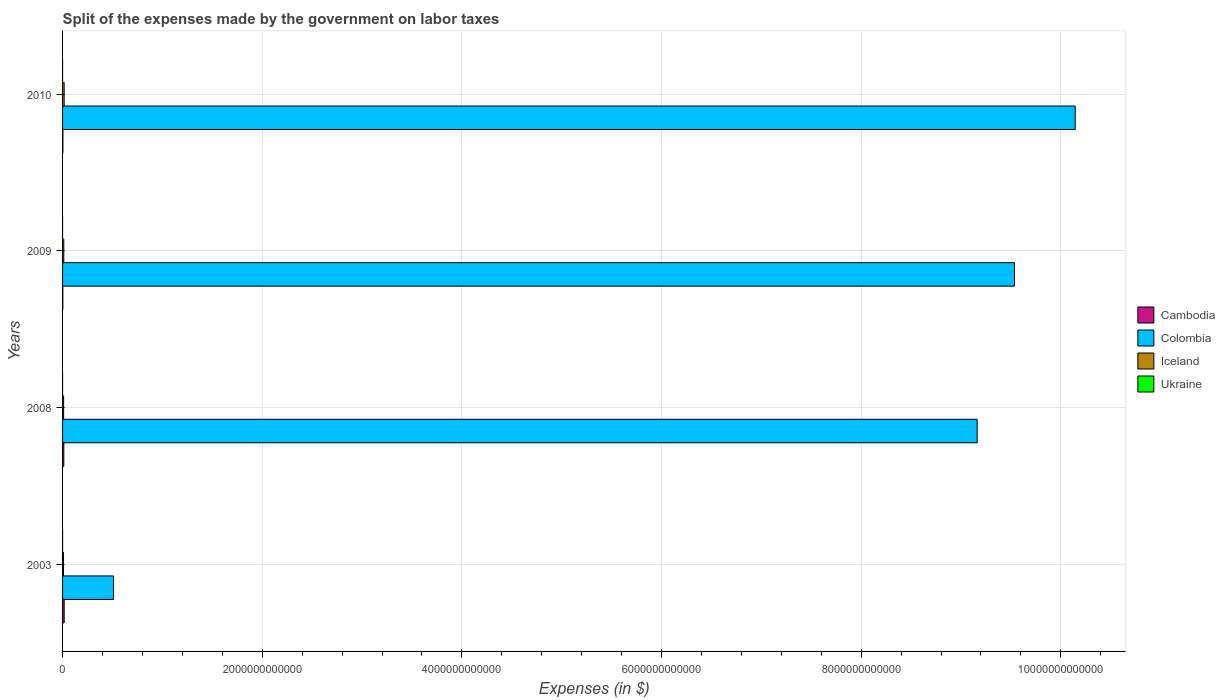How many different coloured bars are there?
Make the answer very short. 4. In how many cases, is the number of bars for a given year not equal to the number of legend labels?
Provide a succinct answer. 0. What is the expenses made by the government on labor taxes in Colombia in 2008?
Provide a short and direct response. 9.16e+12. Across all years, what is the maximum expenses made by the government on labor taxes in Iceland?
Provide a succinct answer. 1.59e+1. Across all years, what is the minimum expenses made by the government on labor taxes in Colombia?
Make the answer very short. 5.11e+11. In which year was the expenses made by the government on labor taxes in Colombia minimum?
Provide a short and direct response. 2003. What is the total expenses made by the government on labor taxes in Iceland in the graph?
Offer a very short reply. 4.86e+1. What is the difference between the expenses made by the government on labor taxes in Iceland in 2003 and that in 2008?
Provide a short and direct response. -9.53e+08. What is the difference between the expenses made by the government on labor taxes in Colombia in 2010 and the expenses made by the government on labor taxes in Cambodia in 2008?
Ensure brevity in your answer.  1.01e+13. What is the average expenses made by the government on labor taxes in Ukraine per year?
Your answer should be very brief. 2.12e+07. In the year 2010, what is the difference between the expenses made by the government on labor taxes in Ukraine and expenses made by the government on labor taxes in Cambodia?
Offer a very short reply. -3.40e+09. In how many years, is the expenses made by the government on labor taxes in Cambodia greater than 9200000000000 $?
Provide a succinct answer. 0. What is the ratio of the expenses made by the government on labor taxes in Ukraine in 2003 to that in 2009?
Make the answer very short. 43.6. Is the expenses made by the government on labor taxes in Iceland in 2003 less than that in 2010?
Provide a succinct answer. Yes. What is the difference between the highest and the second highest expenses made by the government on labor taxes in Colombia?
Offer a terse response. 6.08e+11. What is the difference between the highest and the lowest expenses made by the government on labor taxes in Ukraine?
Provide a succinct answer. 7.74e+07. In how many years, is the expenses made by the government on labor taxes in Iceland greater than the average expenses made by the government on labor taxes in Iceland taken over all years?
Provide a short and direct response. 2. How many years are there in the graph?
Make the answer very short. 4. What is the difference between two consecutive major ticks on the X-axis?
Your response must be concise. 2.00e+12. Are the values on the major ticks of X-axis written in scientific E-notation?
Make the answer very short. No. Does the graph contain any zero values?
Keep it short and to the point. No. Does the graph contain grids?
Offer a terse response. Yes. What is the title of the graph?
Your answer should be very brief. Split of the expenses made by the government on labor taxes. Does "Faeroe Islands" appear as one of the legend labels in the graph?
Keep it short and to the point. No. What is the label or title of the X-axis?
Offer a very short reply. Expenses (in $). What is the Expenses (in $) of Cambodia in 2003?
Your answer should be compact. 1.63e+1. What is the Expenses (in $) in Colombia in 2003?
Make the answer very short. 5.11e+11. What is the Expenses (in $) of Iceland in 2003?
Make the answer very short. 9.70e+09. What is the Expenses (in $) in Ukraine in 2003?
Offer a very short reply. 7.85e+07. What is the Expenses (in $) in Cambodia in 2008?
Provide a short and direct response. 1.25e+1. What is the Expenses (in $) in Colombia in 2008?
Offer a very short reply. 9.16e+12. What is the Expenses (in $) of Iceland in 2008?
Keep it short and to the point. 1.06e+1. What is the Expenses (in $) of Ukraine in 2008?
Offer a terse response. 3.44e+06. What is the Expenses (in $) of Cambodia in 2009?
Offer a terse response. 2.63e+09. What is the Expenses (in $) in Colombia in 2009?
Ensure brevity in your answer.  9.54e+12. What is the Expenses (in $) of Iceland in 2009?
Provide a succinct answer. 1.23e+1. What is the Expenses (in $) of Ukraine in 2009?
Offer a very short reply. 1.80e+06. What is the Expenses (in $) of Cambodia in 2010?
Your answer should be compact. 3.40e+09. What is the Expenses (in $) in Colombia in 2010?
Give a very brief answer. 1.01e+13. What is the Expenses (in $) in Iceland in 2010?
Your answer should be compact. 1.59e+1. What is the Expenses (in $) in Ukraine in 2010?
Provide a short and direct response. 1.08e+06. Across all years, what is the maximum Expenses (in $) of Cambodia?
Ensure brevity in your answer.  1.63e+1. Across all years, what is the maximum Expenses (in $) of Colombia?
Offer a very short reply. 1.01e+13. Across all years, what is the maximum Expenses (in $) of Iceland?
Give a very brief answer. 1.59e+1. Across all years, what is the maximum Expenses (in $) in Ukraine?
Provide a succinct answer. 7.85e+07. Across all years, what is the minimum Expenses (in $) in Cambodia?
Offer a very short reply. 2.63e+09. Across all years, what is the minimum Expenses (in $) of Colombia?
Your answer should be compact. 5.11e+11. Across all years, what is the minimum Expenses (in $) of Iceland?
Offer a terse response. 9.70e+09. Across all years, what is the minimum Expenses (in $) of Ukraine?
Keep it short and to the point. 1.08e+06. What is the total Expenses (in $) of Cambodia in the graph?
Your answer should be very brief. 3.48e+1. What is the total Expenses (in $) of Colombia in the graph?
Offer a terse response. 2.94e+13. What is the total Expenses (in $) of Iceland in the graph?
Make the answer very short. 4.86e+1. What is the total Expenses (in $) in Ukraine in the graph?
Provide a short and direct response. 8.48e+07. What is the difference between the Expenses (in $) in Cambodia in 2003 and that in 2008?
Give a very brief answer. 3.84e+09. What is the difference between the Expenses (in $) of Colombia in 2003 and that in 2008?
Your answer should be compact. -8.65e+12. What is the difference between the Expenses (in $) of Iceland in 2003 and that in 2008?
Offer a very short reply. -9.53e+08. What is the difference between the Expenses (in $) in Ukraine in 2003 and that in 2008?
Make the answer very short. 7.50e+07. What is the difference between the Expenses (in $) of Cambodia in 2003 and that in 2009?
Provide a short and direct response. 1.37e+1. What is the difference between the Expenses (in $) in Colombia in 2003 and that in 2009?
Ensure brevity in your answer.  -9.03e+12. What is the difference between the Expenses (in $) of Iceland in 2003 and that in 2009?
Provide a short and direct response. -2.65e+09. What is the difference between the Expenses (in $) in Ukraine in 2003 and that in 2009?
Your answer should be compact. 7.67e+07. What is the difference between the Expenses (in $) of Cambodia in 2003 and that in 2010?
Provide a succinct answer. 1.29e+1. What is the difference between the Expenses (in $) in Colombia in 2003 and that in 2010?
Make the answer very short. -9.63e+12. What is the difference between the Expenses (in $) in Iceland in 2003 and that in 2010?
Give a very brief answer. -6.17e+09. What is the difference between the Expenses (in $) of Ukraine in 2003 and that in 2010?
Your response must be concise. 7.74e+07. What is the difference between the Expenses (in $) of Cambodia in 2008 and that in 2009?
Your answer should be compact. 9.85e+09. What is the difference between the Expenses (in $) of Colombia in 2008 and that in 2009?
Make the answer very short. -3.74e+11. What is the difference between the Expenses (in $) of Iceland in 2008 and that in 2009?
Offer a very short reply. -1.70e+09. What is the difference between the Expenses (in $) in Ukraine in 2008 and that in 2009?
Make the answer very short. 1.64e+06. What is the difference between the Expenses (in $) in Cambodia in 2008 and that in 2010?
Offer a terse response. 9.07e+09. What is the difference between the Expenses (in $) of Colombia in 2008 and that in 2010?
Your answer should be very brief. -9.82e+11. What is the difference between the Expenses (in $) in Iceland in 2008 and that in 2010?
Make the answer very short. -5.21e+09. What is the difference between the Expenses (in $) in Ukraine in 2008 and that in 2010?
Provide a succinct answer. 2.36e+06. What is the difference between the Expenses (in $) in Cambodia in 2009 and that in 2010?
Ensure brevity in your answer.  -7.72e+08. What is the difference between the Expenses (in $) in Colombia in 2009 and that in 2010?
Keep it short and to the point. -6.08e+11. What is the difference between the Expenses (in $) of Iceland in 2009 and that in 2010?
Your response must be concise. -3.52e+09. What is the difference between the Expenses (in $) in Ukraine in 2009 and that in 2010?
Provide a succinct answer. 7.20e+05. What is the difference between the Expenses (in $) in Cambodia in 2003 and the Expenses (in $) in Colombia in 2008?
Give a very brief answer. -9.15e+12. What is the difference between the Expenses (in $) in Cambodia in 2003 and the Expenses (in $) in Iceland in 2008?
Your answer should be very brief. 5.66e+09. What is the difference between the Expenses (in $) of Cambodia in 2003 and the Expenses (in $) of Ukraine in 2008?
Your answer should be very brief. 1.63e+1. What is the difference between the Expenses (in $) of Colombia in 2003 and the Expenses (in $) of Iceland in 2008?
Offer a very short reply. 5.00e+11. What is the difference between the Expenses (in $) in Colombia in 2003 and the Expenses (in $) in Ukraine in 2008?
Offer a very short reply. 5.11e+11. What is the difference between the Expenses (in $) in Iceland in 2003 and the Expenses (in $) in Ukraine in 2008?
Offer a terse response. 9.69e+09. What is the difference between the Expenses (in $) of Cambodia in 2003 and the Expenses (in $) of Colombia in 2009?
Offer a very short reply. -9.52e+12. What is the difference between the Expenses (in $) of Cambodia in 2003 and the Expenses (in $) of Iceland in 2009?
Ensure brevity in your answer.  3.97e+09. What is the difference between the Expenses (in $) of Cambodia in 2003 and the Expenses (in $) of Ukraine in 2009?
Make the answer very short. 1.63e+1. What is the difference between the Expenses (in $) of Colombia in 2003 and the Expenses (in $) of Iceland in 2009?
Offer a very short reply. 4.98e+11. What is the difference between the Expenses (in $) of Colombia in 2003 and the Expenses (in $) of Ukraine in 2009?
Ensure brevity in your answer.  5.11e+11. What is the difference between the Expenses (in $) in Iceland in 2003 and the Expenses (in $) in Ukraine in 2009?
Provide a succinct answer. 9.69e+09. What is the difference between the Expenses (in $) of Cambodia in 2003 and the Expenses (in $) of Colombia in 2010?
Your response must be concise. -1.01e+13. What is the difference between the Expenses (in $) in Cambodia in 2003 and the Expenses (in $) in Iceland in 2010?
Ensure brevity in your answer.  4.51e+08. What is the difference between the Expenses (in $) in Cambodia in 2003 and the Expenses (in $) in Ukraine in 2010?
Your response must be concise. 1.63e+1. What is the difference between the Expenses (in $) of Colombia in 2003 and the Expenses (in $) of Iceland in 2010?
Keep it short and to the point. 4.95e+11. What is the difference between the Expenses (in $) in Colombia in 2003 and the Expenses (in $) in Ukraine in 2010?
Offer a very short reply. 5.11e+11. What is the difference between the Expenses (in $) in Iceland in 2003 and the Expenses (in $) in Ukraine in 2010?
Provide a succinct answer. 9.70e+09. What is the difference between the Expenses (in $) in Cambodia in 2008 and the Expenses (in $) in Colombia in 2009?
Provide a short and direct response. -9.52e+12. What is the difference between the Expenses (in $) in Cambodia in 2008 and the Expenses (in $) in Iceland in 2009?
Your response must be concise. 1.30e+08. What is the difference between the Expenses (in $) in Cambodia in 2008 and the Expenses (in $) in Ukraine in 2009?
Provide a succinct answer. 1.25e+1. What is the difference between the Expenses (in $) of Colombia in 2008 and the Expenses (in $) of Iceland in 2009?
Ensure brevity in your answer.  9.15e+12. What is the difference between the Expenses (in $) of Colombia in 2008 and the Expenses (in $) of Ukraine in 2009?
Provide a succinct answer. 9.16e+12. What is the difference between the Expenses (in $) in Iceland in 2008 and the Expenses (in $) in Ukraine in 2009?
Keep it short and to the point. 1.06e+1. What is the difference between the Expenses (in $) of Cambodia in 2008 and the Expenses (in $) of Colombia in 2010?
Your answer should be very brief. -1.01e+13. What is the difference between the Expenses (in $) in Cambodia in 2008 and the Expenses (in $) in Iceland in 2010?
Your answer should be compact. -3.39e+09. What is the difference between the Expenses (in $) of Cambodia in 2008 and the Expenses (in $) of Ukraine in 2010?
Your answer should be very brief. 1.25e+1. What is the difference between the Expenses (in $) in Colombia in 2008 and the Expenses (in $) in Iceland in 2010?
Your answer should be compact. 9.15e+12. What is the difference between the Expenses (in $) in Colombia in 2008 and the Expenses (in $) in Ukraine in 2010?
Offer a terse response. 9.16e+12. What is the difference between the Expenses (in $) in Iceland in 2008 and the Expenses (in $) in Ukraine in 2010?
Give a very brief answer. 1.06e+1. What is the difference between the Expenses (in $) of Cambodia in 2009 and the Expenses (in $) of Colombia in 2010?
Ensure brevity in your answer.  -1.01e+13. What is the difference between the Expenses (in $) of Cambodia in 2009 and the Expenses (in $) of Iceland in 2010?
Provide a succinct answer. -1.32e+1. What is the difference between the Expenses (in $) of Cambodia in 2009 and the Expenses (in $) of Ukraine in 2010?
Keep it short and to the point. 2.63e+09. What is the difference between the Expenses (in $) of Colombia in 2009 and the Expenses (in $) of Iceland in 2010?
Your response must be concise. 9.52e+12. What is the difference between the Expenses (in $) in Colombia in 2009 and the Expenses (in $) in Ukraine in 2010?
Give a very brief answer. 9.54e+12. What is the difference between the Expenses (in $) in Iceland in 2009 and the Expenses (in $) in Ukraine in 2010?
Your response must be concise. 1.23e+1. What is the average Expenses (in $) of Cambodia per year?
Offer a very short reply. 8.71e+09. What is the average Expenses (in $) of Colombia per year?
Your answer should be compact. 7.34e+12. What is the average Expenses (in $) in Iceland per year?
Make the answer very short. 1.21e+1. What is the average Expenses (in $) of Ukraine per year?
Provide a succinct answer. 2.12e+07. In the year 2003, what is the difference between the Expenses (in $) of Cambodia and Expenses (in $) of Colombia?
Offer a very short reply. -4.95e+11. In the year 2003, what is the difference between the Expenses (in $) in Cambodia and Expenses (in $) in Iceland?
Your response must be concise. 6.62e+09. In the year 2003, what is the difference between the Expenses (in $) in Cambodia and Expenses (in $) in Ukraine?
Offer a terse response. 1.62e+1. In the year 2003, what is the difference between the Expenses (in $) in Colombia and Expenses (in $) in Iceland?
Provide a short and direct response. 5.01e+11. In the year 2003, what is the difference between the Expenses (in $) of Colombia and Expenses (in $) of Ukraine?
Offer a terse response. 5.11e+11. In the year 2003, what is the difference between the Expenses (in $) in Iceland and Expenses (in $) in Ukraine?
Provide a succinct answer. 9.62e+09. In the year 2008, what is the difference between the Expenses (in $) in Cambodia and Expenses (in $) in Colombia?
Provide a short and direct response. -9.15e+12. In the year 2008, what is the difference between the Expenses (in $) in Cambodia and Expenses (in $) in Iceland?
Offer a terse response. 1.83e+09. In the year 2008, what is the difference between the Expenses (in $) in Cambodia and Expenses (in $) in Ukraine?
Give a very brief answer. 1.25e+1. In the year 2008, what is the difference between the Expenses (in $) of Colombia and Expenses (in $) of Iceland?
Offer a terse response. 9.15e+12. In the year 2008, what is the difference between the Expenses (in $) in Colombia and Expenses (in $) in Ukraine?
Keep it short and to the point. 9.16e+12. In the year 2008, what is the difference between the Expenses (in $) of Iceland and Expenses (in $) of Ukraine?
Provide a short and direct response. 1.06e+1. In the year 2009, what is the difference between the Expenses (in $) of Cambodia and Expenses (in $) of Colombia?
Give a very brief answer. -9.53e+12. In the year 2009, what is the difference between the Expenses (in $) in Cambodia and Expenses (in $) in Iceland?
Keep it short and to the point. -9.72e+09. In the year 2009, what is the difference between the Expenses (in $) of Cambodia and Expenses (in $) of Ukraine?
Ensure brevity in your answer.  2.63e+09. In the year 2009, what is the difference between the Expenses (in $) in Colombia and Expenses (in $) in Iceland?
Offer a very short reply. 9.52e+12. In the year 2009, what is the difference between the Expenses (in $) of Colombia and Expenses (in $) of Ukraine?
Provide a succinct answer. 9.54e+12. In the year 2009, what is the difference between the Expenses (in $) in Iceland and Expenses (in $) in Ukraine?
Keep it short and to the point. 1.23e+1. In the year 2010, what is the difference between the Expenses (in $) of Cambodia and Expenses (in $) of Colombia?
Offer a very short reply. -1.01e+13. In the year 2010, what is the difference between the Expenses (in $) in Cambodia and Expenses (in $) in Iceland?
Your answer should be compact. -1.25e+1. In the year 2010, what is the difference between the Expenses (in $) of Cambodia and Expenses (in $) of Ukraine?
Ensure brevity in your answer.  3.40e+09. In the year 2010, what is the difference between the Expenses (in $) in Colombia and Expenses (in $) in Iceland?
Ensure brevity in your answer.  1.01e+13. In the year 2010, what is the difference between the Expenses (in $) in Colombia and Expenses (in $) in Ukraine?
Provide a short and direct response. 1.01e+13. In the year 2010, what is the difference between the Expenses (in $) in Iceland and Expenses (in $) in Ukraine?
Provide a short and direct response. 1.59e+1. What is the ratio of the Expenses (in $) in Cambodia in 2003 to that in 2008?
Offer a terse response. 1.31. What is the ratio of the Expenses (in $) in Colombia in 2003 to that in 2008?
Keep it short and to the point. 0.06. What is the ratio of the Expenses (in $) in Iceland in 2003 to that in 2008?
Your answer should be compact. 0.91. What is the ratio of the Expenses (in $) in Ukraine in 2003 to that in 2008?
Provide a succinct answer. 22.81. What is the ratio of the Expenses (in $) of Cambodia in 2003 to that in 2009?
Provide a short and direct response. 6.2. What is the ratio of the Expenses (in $) in Colombia in 2003 to that in 2009?
Provide a short and direct response. 0.05. What is the ratio of the Expenses (in $) of Iceland in 2003 to that in 2009?
Ensure brevity in your answer.  0.79. What is the ratio of the Expenses (in $) of Ukraine in 2003 to that in 2009?
Offer a very short reply. 43.6. What is the ratio of the Expenses (in $) of Cambodia in 2003 to that in 2010?
Your response must be concise. 4.79. What is the ratio of the Expenses (in $) in Colombia in 2003 to that in 2010?
Your answer should be very brief. 0.05. What is the ratio of the Expenses (in $) in Iceland in 2003 to that in 2010?
Your response must be concise. 0.61. What is the ratio of the Expenses (in $) in Ukraine in 2003 to that in 2010?
Keep it short and to the point. 72.66. What is the ratio of the Expenses (in $) of Cambodia in 2008 to that in 2009?
Provide a short and direct response. 4.74. What is the ratio of the Expenses (in $) in Colombia in 2008 to that in 2009?
Ensure brevity in your answer.  0.96. What is the ratio of the Expenses (in $) of Iceland in 2008 to that in 2009?
Your response must be concise. 0.86. What is the ratio of the Expenses (in $) of Ukraine in 2008 to that in 2009?
Ensure brevity in your answer.  1.91. What is the ratio of the Expenses (in $) in Cambodia in 2008 to that in 2010?
Provide a succinct answer. 3.66. What is the ratio of the Expenses (in $) in Colombia in 2008 to that in 2010?
Your response must be concise. 0.9. What is the ratio of the Expenses (in $) in Iceland in 2008 to that in 2010?
Your answer should be compact. 0.67. What is the ratio of the Expenses (in $) in Ukraine in 2008 to that in 2010?
Your answer should be very brief. 3.19. What is the ratio of the Expenses (in $) of Cambodia in 2009 to that in 2010?
Keep it short and to the point. 0.77. What is the ratio of the Expenses (in $) of Colombia in 2009 to that in 2010?
Your response must be concise. 0.94. What is the ratio of the Expenses (in $) in Iceland in 2009 to that in 2010?
Give a very brief answer. 0.78. What is the difference between the highest and the second highest Expenses (in $) of Cambodia?
Ensure brevity in your answer.  3.84e+09. What is the difference between the highest and the second highest Expenses (in $) in Colombia?
Offer a very short reply. 6.08e+11. What is the difference between the highest and the second highest Expenses (in $) of Iceland?
Your response must be concise. 3.52e+09. What is the difference between the highest and the second highest Expenses (in $) of Ukraine?
Your answer should be compact. 7.50e+07. What is the difference between the highest and the lowest Expenses (in $) of Cambodia?
Your response must be concise. 1.37e+1. What is the difference between the highest and the lowest Expenses (in $) in Colombia?
Provide a short and direct response. 9.63e+12. What is the difference between the highest and the lowest Expenses (in $) of Iceland?
Your response must be concise. 6.17e+09. What is the difference between the highest and the lowest Expenses (in $) of Ukraine?
Keep it short and to the point. 7.74e+07. 